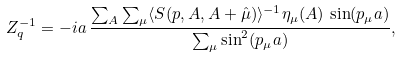<formula> <loc_0><loc_0><loc_500><loc_500>Z _ { q } ^ { - 1 } = - i a \, \frac { \sum _ { A } \sum _ { \mu } \langle S ( p , A , A + \hat { \mu } ) \rangle ^ { - 1 } \eta _ { \mu } ( A ) \, \sin ( p _ { \mu } a ) } { \sum _ { \mu } \sin ^ { 2 } ( p _ { \mu } a ) } ,</formula> 